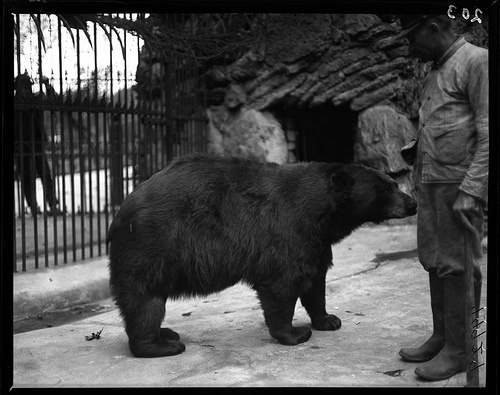Describe the objects in this image and their specific colors. I can see bear in black, gray, darkgray, and lightgray tones, people in black, gray, and white tones, and people in black, gray, darkgray, and lightgray tones in this image. 